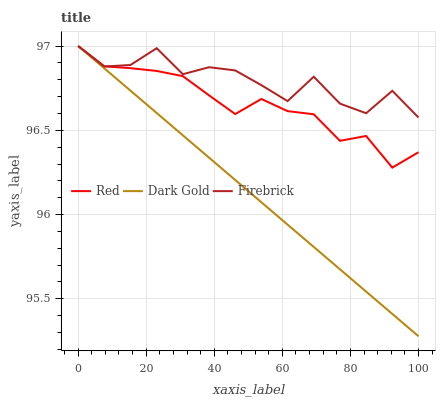Does Dark Gold have the minimum area under the curve?
Answer yes or no. Yes. Does Firebrick have the maximum area under the curve?
Answer yes or no. Yes. Does Red have the minimum area under the curve?
Answer yes or no. No. Does Red have the maximum area under the curve?
Answer yes or no. No. Is Dark Gold the smoothest?
Answer yes or no. Yes. Is Firebrick the roughest?
Answer yes or no. Yes. Is Red the smoothest?
Answer yes or no. No. Is Red the roughest?
Answer yes or no. No. Does Red have the lowest value?
Answer yes or no. No. Does Dark Gold have the highest value?
Answer yes or no. Yes. Does Firebrick intersect Red?
Answer yes or no. Yes. Is Firebrick less than Red?
Answer yes or no. No. Is Firebrick greater than Red?
Answer yes or no. No. 